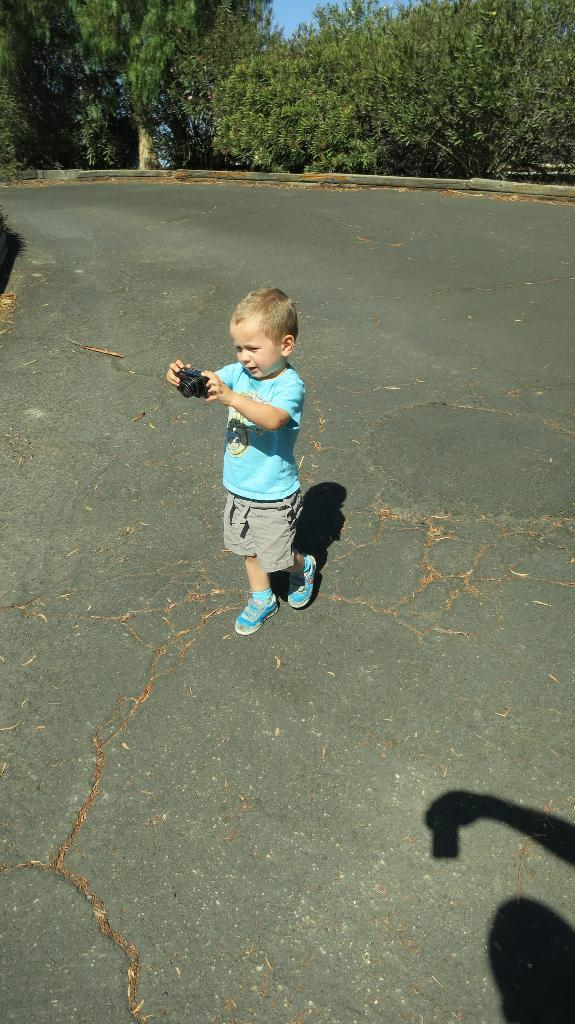What is the boy in the image doing? The boy is standing and holding a camera in the image. Can you describe the shadow in the image? The shadow in the image is of another person holding an object. What can be seen in the background of the image? There are trees and the sky visible in the background of the image. What type of glove is the boy wearing in the image? The boy is not wearing a glove in the image. Can you see a kettle in the image? There is no kettle present in the image. 